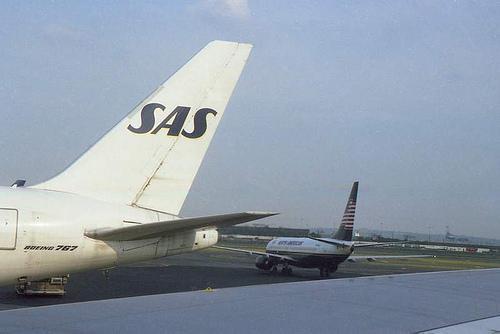How many planes are there?
Give a very brief answer. 2. 